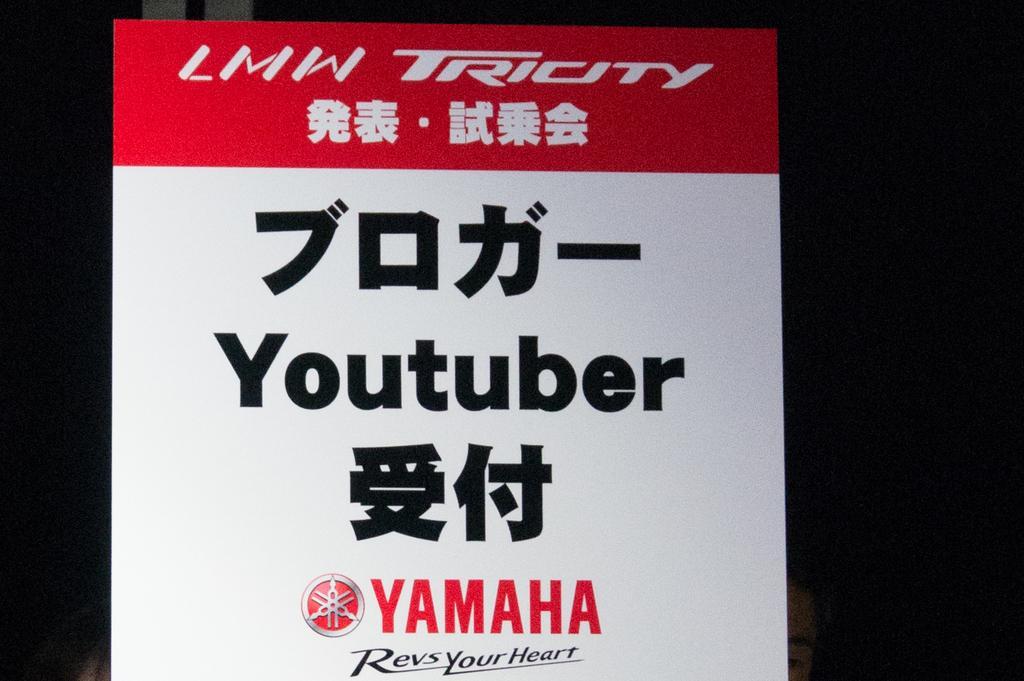In one or two sentences, can you explain what this image depicts? In this image I can see a red and white colour board and on it I can see something is written. I can also see black colour in the background. 